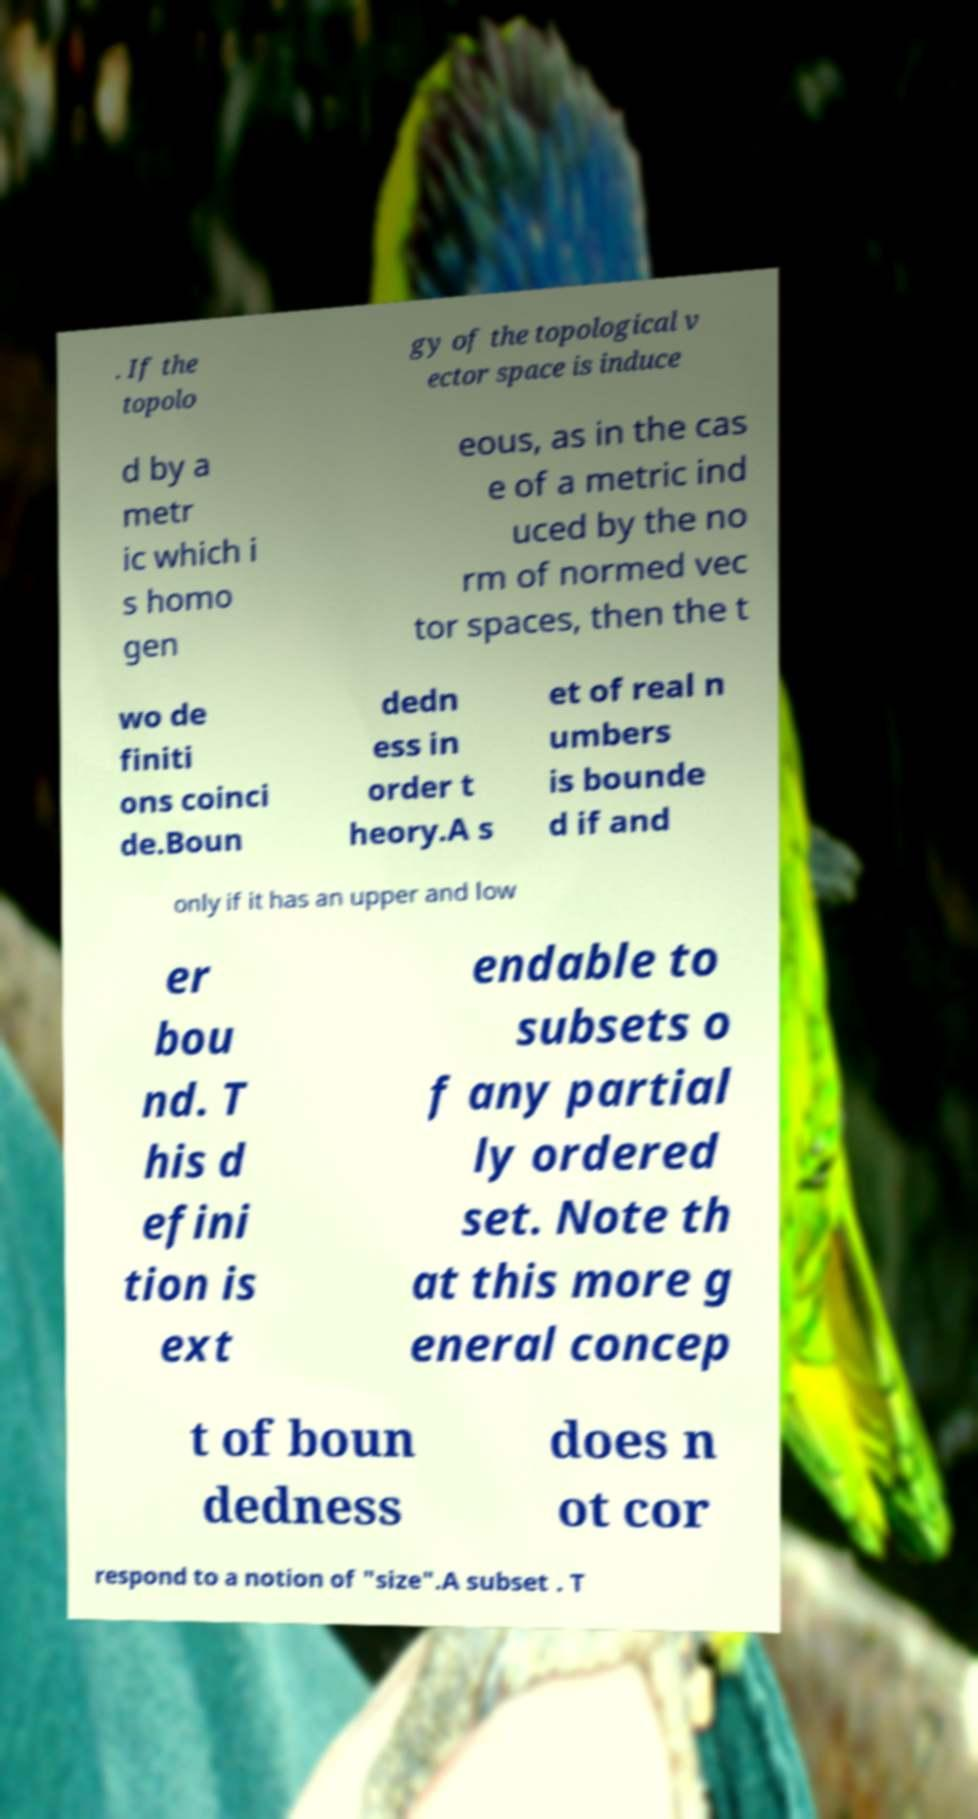There's text embedded in this image that I need extracted. Can you transcribe it verbatim? . If the topolo gy of the topological v ector space is induce d by a metr ic which i s homo gen eous, as in the cas e of a metric ind uced by the no rm of normed vec tor spaces, then the t wo de finiti ons coinci de.Boun dedn ess in order t heory.A s et of real n umbers is bounde d if and only if it has an upper and low er bou nd. T his d efini tion is ext endable to subsets o f any partial ly ordered set. Note th at this more g eneral concep t of boun dedness does n ot cor respond to a notion of "size".A subset . T 